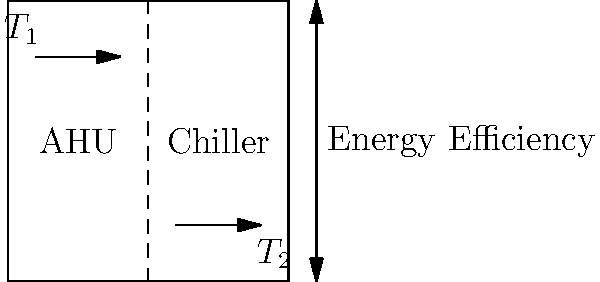In the given HVAC system schematic, which strategy would most likely improve energy efficiency based on the temperature indicators $T_1$ and $T_2$? To answer this question, we need to analyze the HVAC system schematic and understand the relationship between the components and temperature indicators:

1. The schematic shows a simplified HVAC system with an Air Handling Unit (AHU) and a Chiller.

2. $T_1$ is located near the top of the AHU, likely indicating the supply air temperature.

3. $T_2$ is located near the bottom of the Chiller, likely indicating the return water temperature.

4. The arrows indicate the direction of airflow and water flow in the system.

5. To improve energy efficiency, we need to focus on reducing the temperature difference between $T_1$ and $T_2$.

6. The most effective strategy would be to implement a variable speed drive (VSD) on the chiller. This would allow the chiller to adjust its output based on the actual cooling demand, rather than running at full capacity all the time.

7. By using a VSD, the chiller can modulate its speed to maintain the desired temperature difference between $T_1$ and $T_2$ more efficiently, reducing energy consumption during periods of lower demand.

8. This strategy would also help to maintain a more consistent temperature throughout the system, improving overall comfort and reducing wear on the equipment.
Answer: Implement a variable speed drive (VSD) on the chiller 